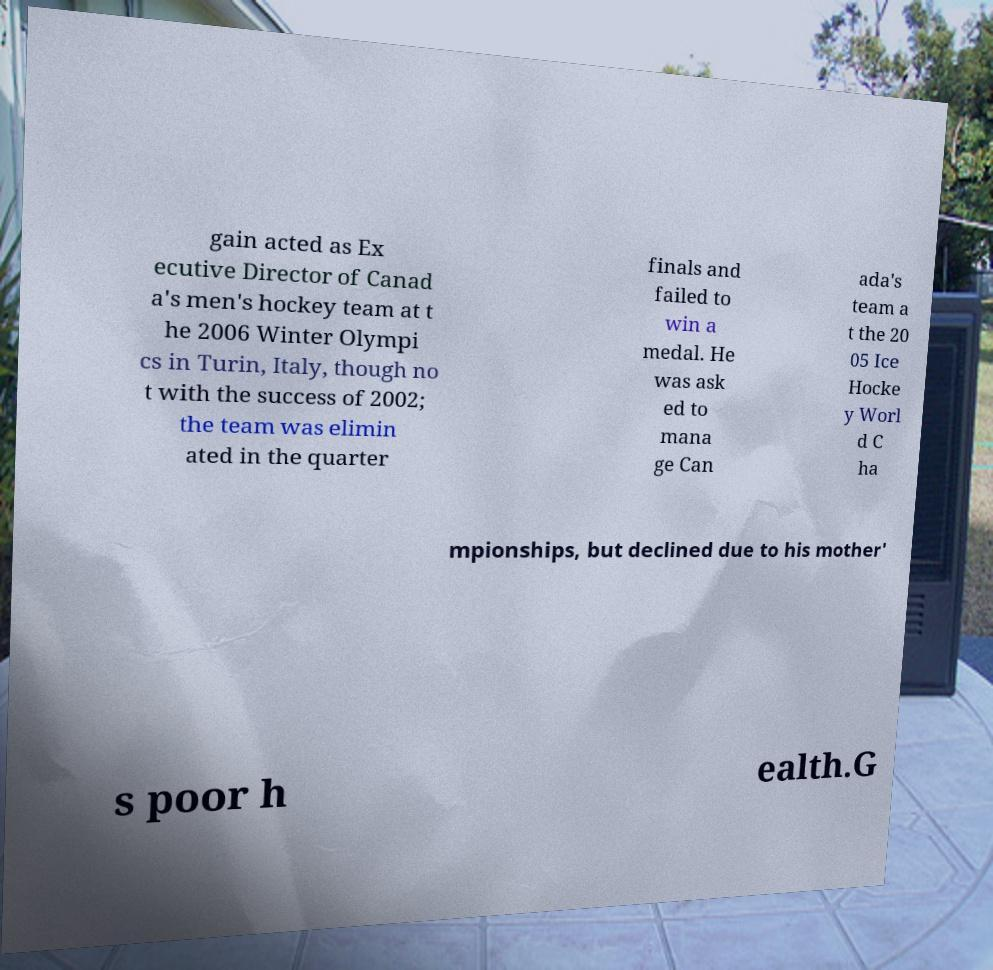Please identify and transcribe the text found in this image. gain acted as Ex ecutive Director of Canad a's men's hockey team at t he 2006 Winter Olympi cs in Turin, Italy, though no t with the success of 2002; the team was elimin ated in the quarter finals and failed to win a medal. He was ask ed to mana ge Can ada's team a t the 20 05 Ice Hocke y Worl d C ha mpionships, but declined due to his mother' s poor h ealth.G 